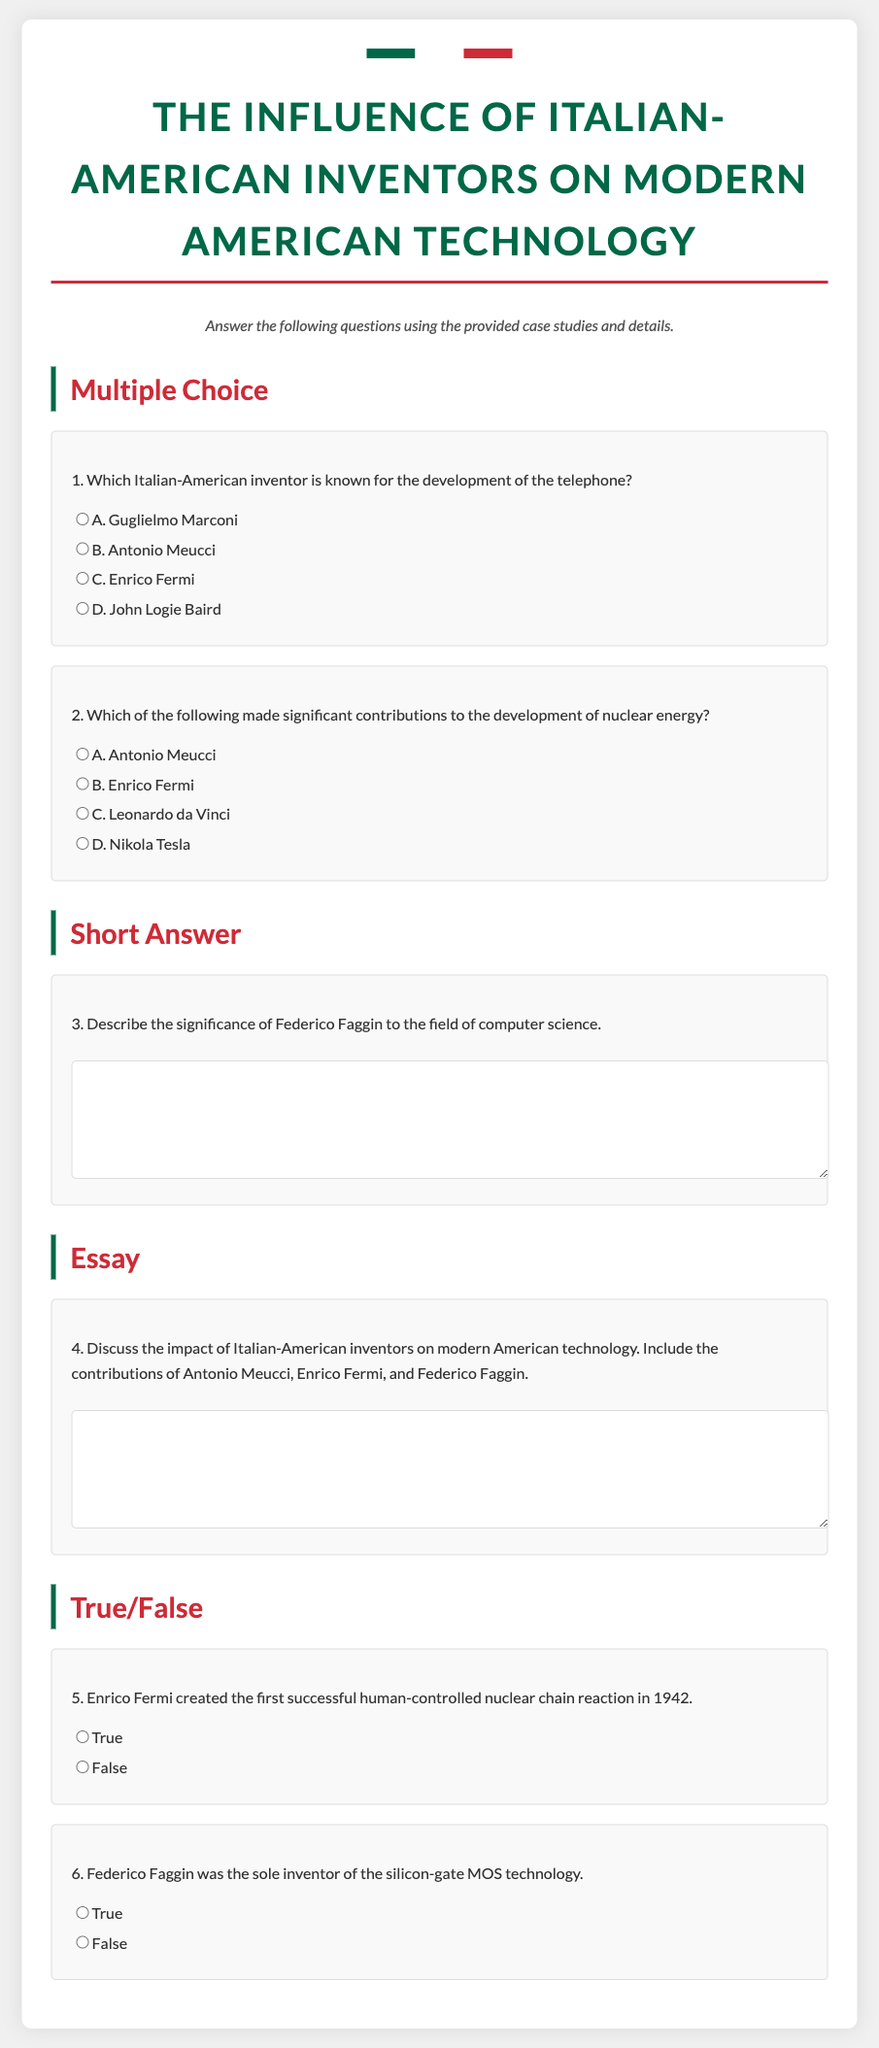What is the title of the exam? The title of the exam is displayed prominently at the top of the document, which is "The Influence of Italian-American Inventors on Modern American Technology."
Answer: The Influence of Italian-American Inventors on Modern American Technology Who is the inventor known for the development of the telephone? The multiple choice section lists Guglielmo Marconi, Antonio Meucci, Enrico Fermi, and John Logie Baird as options, with Antonio Meucci being known for the telephone.
Answer: Antonio Meucci What significant contribution did Enrico Fermi make? The document states that Enrico Fermi made significant contributions to the development of nuclear energy.
Answer: Nuclear energy In what year did Enrico Fermi create the first successful human-controlled nuclear chain reaction? The true/false question indicates that this event occurred in 1942.
Answer: 1942 What technology did Federico Faggin invent? The document mentions that Federico Faggin was the sole inventor of the silicon-gate MOS technology.
Answer: Silicon-gate MOS technology What type of questions are included in the exam? The exam consists of multiple choice, short answer, essay, and true/false question types.
Answer: Multiple choice, short answer, essay, true/false How many questions are there in total? The document lists a total of six questions in different categories.
Answer: Six What color is used for the title text? The title text is colored in a shade of green that matches the Italian flag's green section.
Answer: Green What is the color scheme representing in the exam? The color scheme of green, white, and red represents the colors of the Italian flag, showcased at the top of the document.
Answer: Italian flag colors 